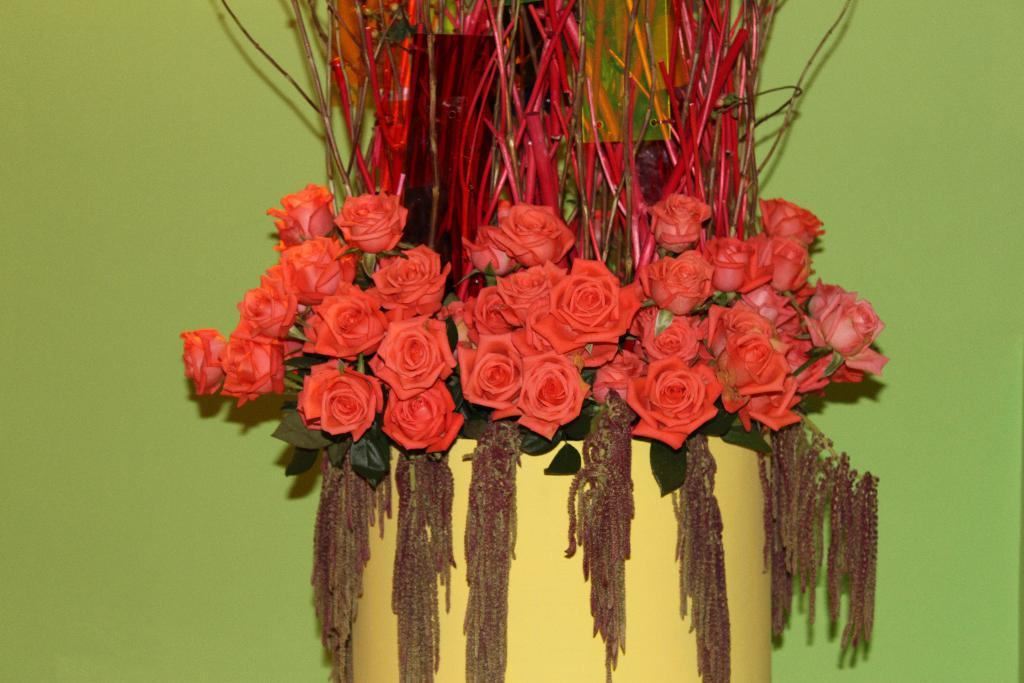What is the main object in the center of the image? There is a flower vase in the center of the image. What type of bone can be seen in the image? There is no bone present in the image; it features a flower vase. What fictional character is wearing a skirt in the image? There are no fictional characters or skirts present in the image. 